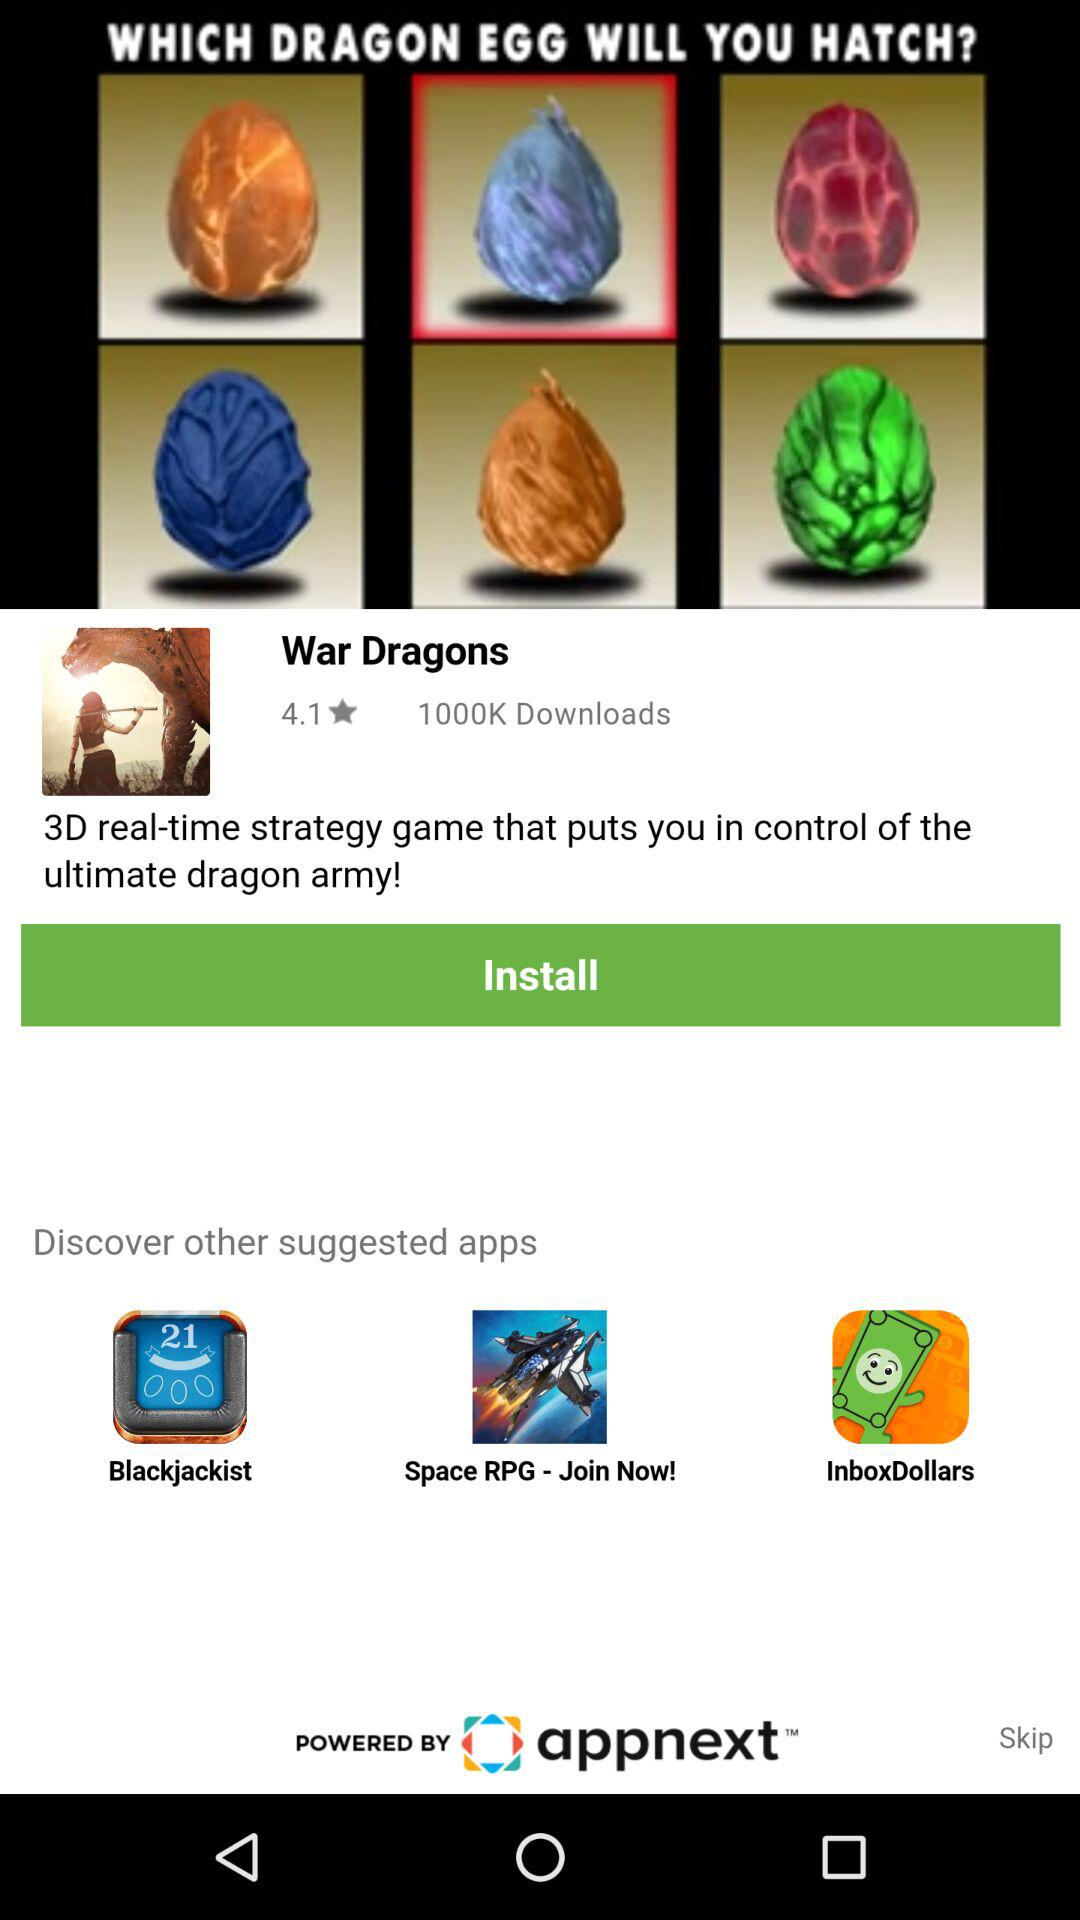What is the rating for "War Dragons"? The rating is 4.1. 